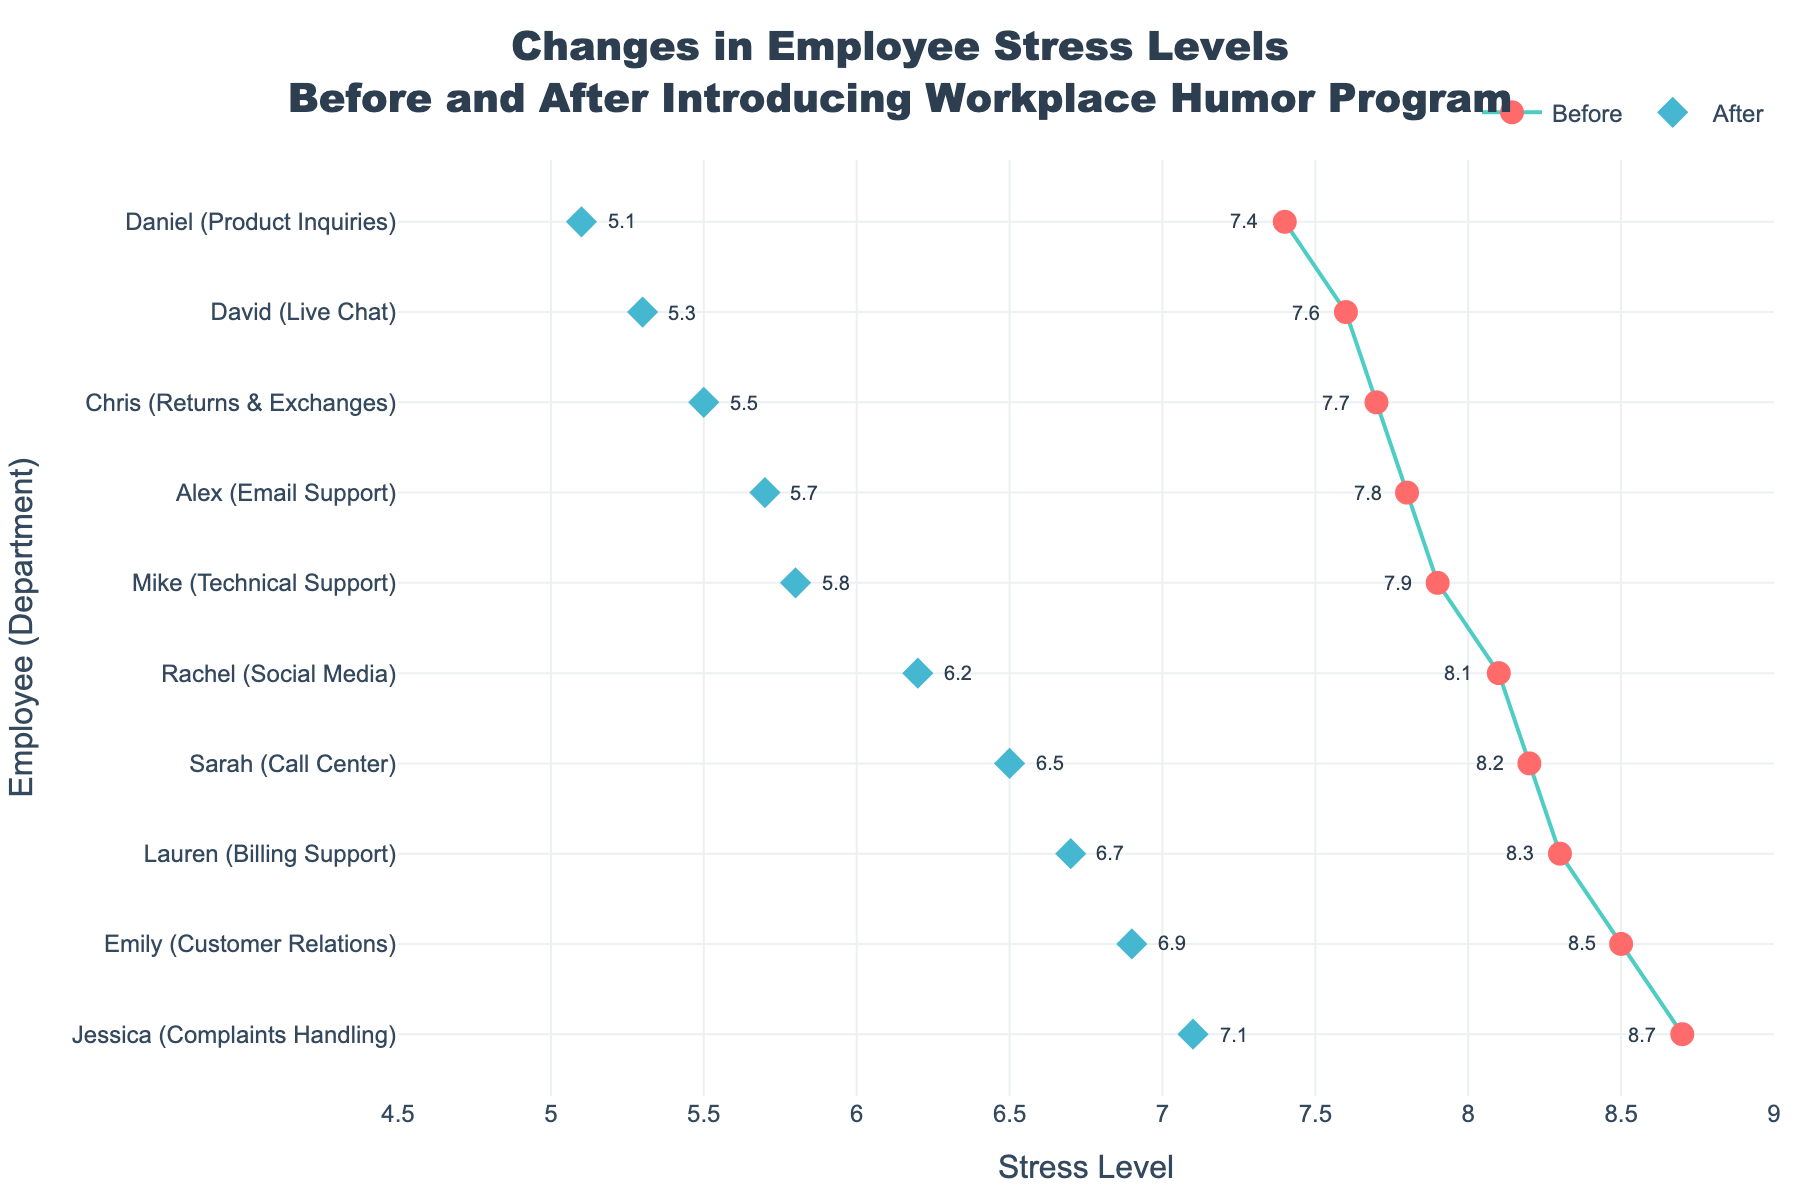What's the title of the plot? The title is located at the top center of the figure in a larger font size.
Answer: Changes in Employee Stress Levels Before and After Introducing Workplace Humor Program What do the two colors of the markers represent? The two colors differentiate between the stress levels before and after the humor program. The circles indicate "Before" (red) and the diamonds indicate "After" (blue).
Answer: Before and After stress levels Which employee showed the largest decrease in stress level? Locate the employee with the largest difference between the markers joined by the line, check the difference between the left (Before) and right (After) marker.
Answer: David (Live Chat) What is the average stress level before the humor program? Add all the "Stress_Before" values and divide by the number of employees. (8.2+7.9+8.5+7.6+8.1+7.8+8.7+7.4+8.3+7.7)/10 = 8.02
Answer: 8.02 Which department had the smallest decrease in stress level? Look for the pair of markers with the smallest distance between them.
Answer: Jessica (Complaints Handling) Is there any employee whose stress level increased after the humor program? Identify if any right marker (After) is to the left of a corresponding left marker (Before). In this case, there should be no such instance.
Answer: No What was Sarah's stress level after the humor program? Find the corresponding diamond marker on Sarah's row in the figure.
Answer: 6.5 How many employees had a stress level of 8.5 or higher before the humor program? Count employees whose "Before" stress markers are at 8.5 or higher values.
Answer: 3 What is the median stress level after the humor program? Order the "Stress_After" values and find the middle value. (5.1, 5.3, 5.5, 5.7, 5.8, 6.2, 6.5, 6.7, 6.9, 7.1). The middle values are 5.8 and 6.2, so median is (5.8 + 6.2)/2 = 6
Answer: 6 Which employee has the highest stress level after the humor program? Identify the topmost diamond marker among all employees.
Answer: Jessica (Complaints Handling) 